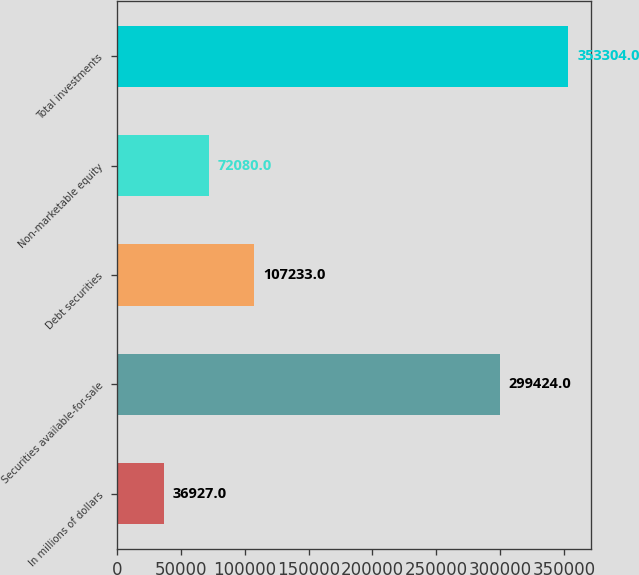<chart> <loc_0><loc_0><loc_500><loc_500><bar_chart><fcel>In millions of dollars<fcel>Securities available-for-sale<fcel>Debt securities<fcel>Non-marketable equity<fcel>Total investments<nl><fcel>36927<fcel>299424<fcel>107233<fcel>72080<fcel>353304<nl></chart> 